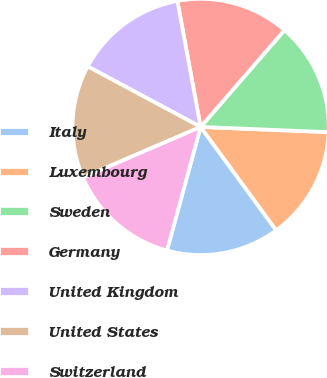Convert chart to OTSL. <chart><loc_0><loc_0><loc_500><loc_500><pie_chart><fcel>Italy<fcel>Luxembourg<fcel>Sweden<fcel>Germany<fcel>United Kingdom<fcel>United States<fcel>Switzerland<nl><fcel>14.28%<fcel>14.3%<fcel>14.29%<fcel>14.27%<fcel>14.27%<fcel>14.3%<fcel>14.29%<nl></chart> 